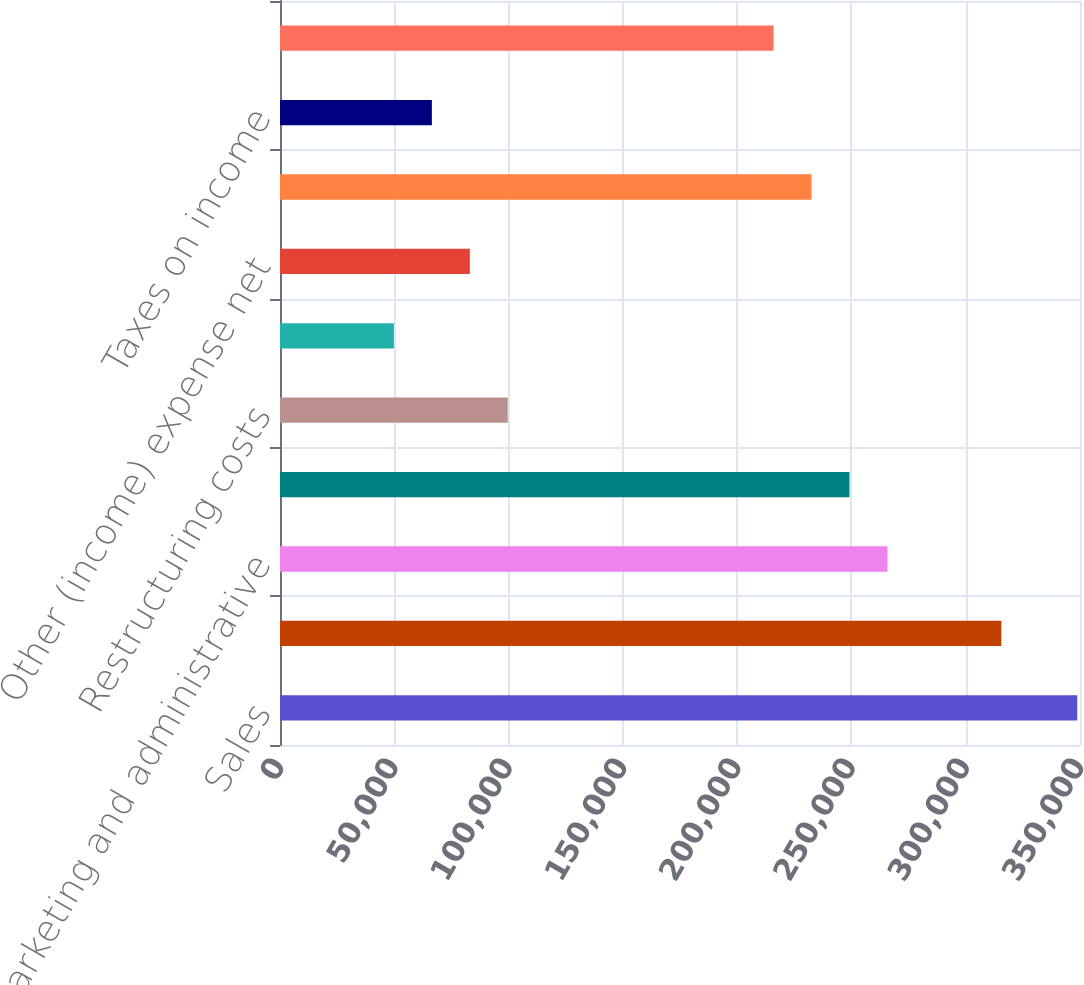Convert chart. <chart><loc_0><loc_0><loc_500><loc_500><bar_chart><fcel>Sales<fcel>Materials and production<fcel>Marketing and administrative<fcel>Research and development<fcel>Restructuring costs<fcel>Equity income from affiliates<fcel>Other (income) expense net<fcel>Income before taxes<fcel>Taxes on income<fcel>Net income<nl><fcel>348808<fcel>315588<fcel>265759<fcel>249149<fcel>99660.8<fcel>49831.4<fcel>83051<fcel>232539<fcel>66441.2<fcel>215929<nl></chart> 